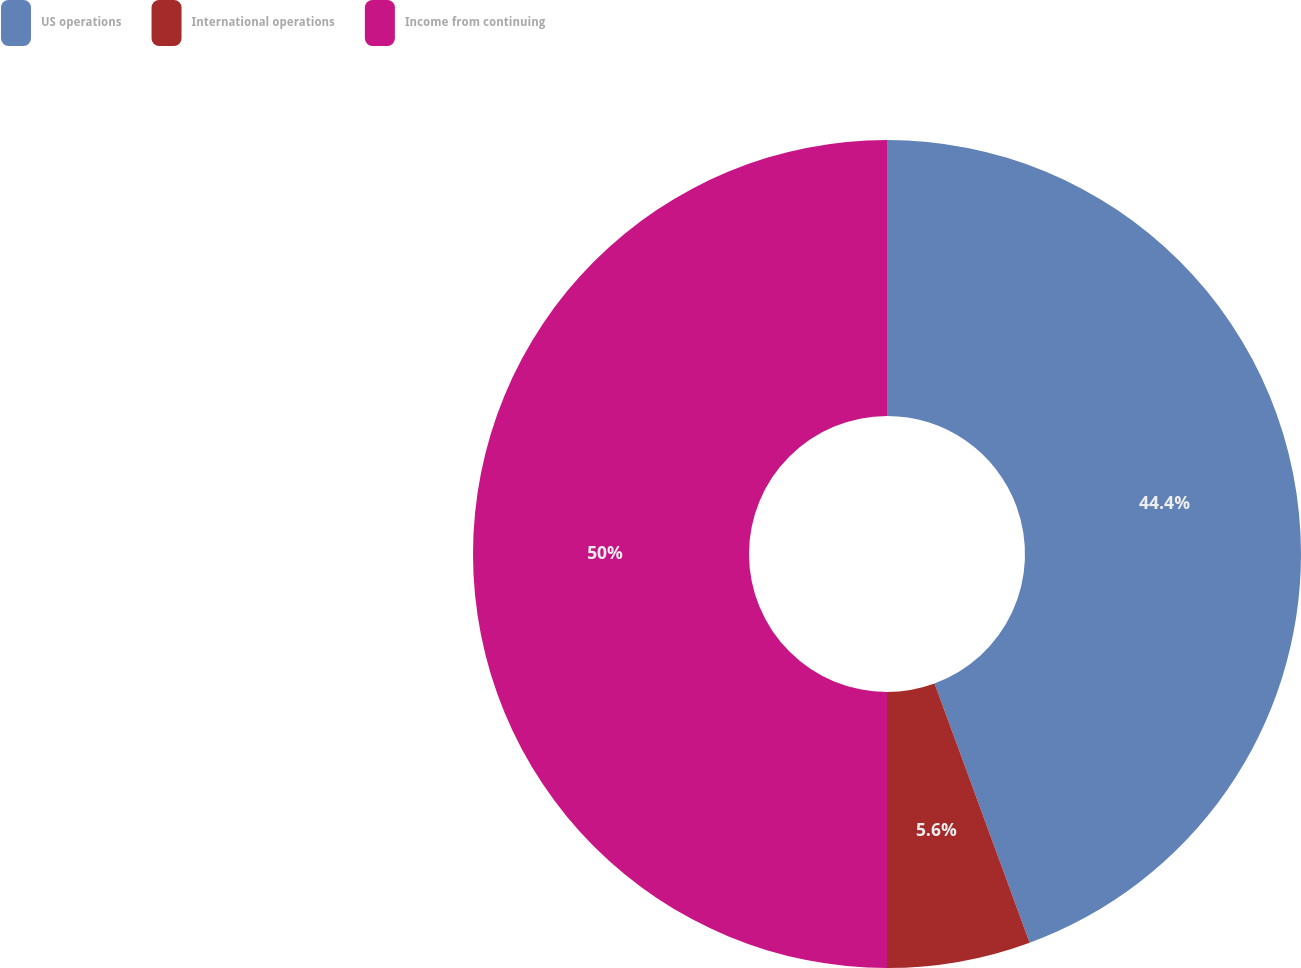Convert chart. <chart><loc_0><loc_0><loc_500><loc_500><pie_chart><fcel>US operations<fcel>International operations<fcel>Income from continuing<nl><fcel>44.4%<fcel>5.6%<fcel>50.0%<nl></chart> 